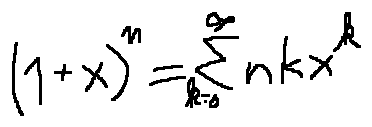Convert formula to latex. <formula><loc_0><loc_0><loc_500><loc_500>( 1 + x ) ^ { n } = \sum \lim i t s _ { k = 0 } ^ { \infty } n k x ^ { k }</formula> 